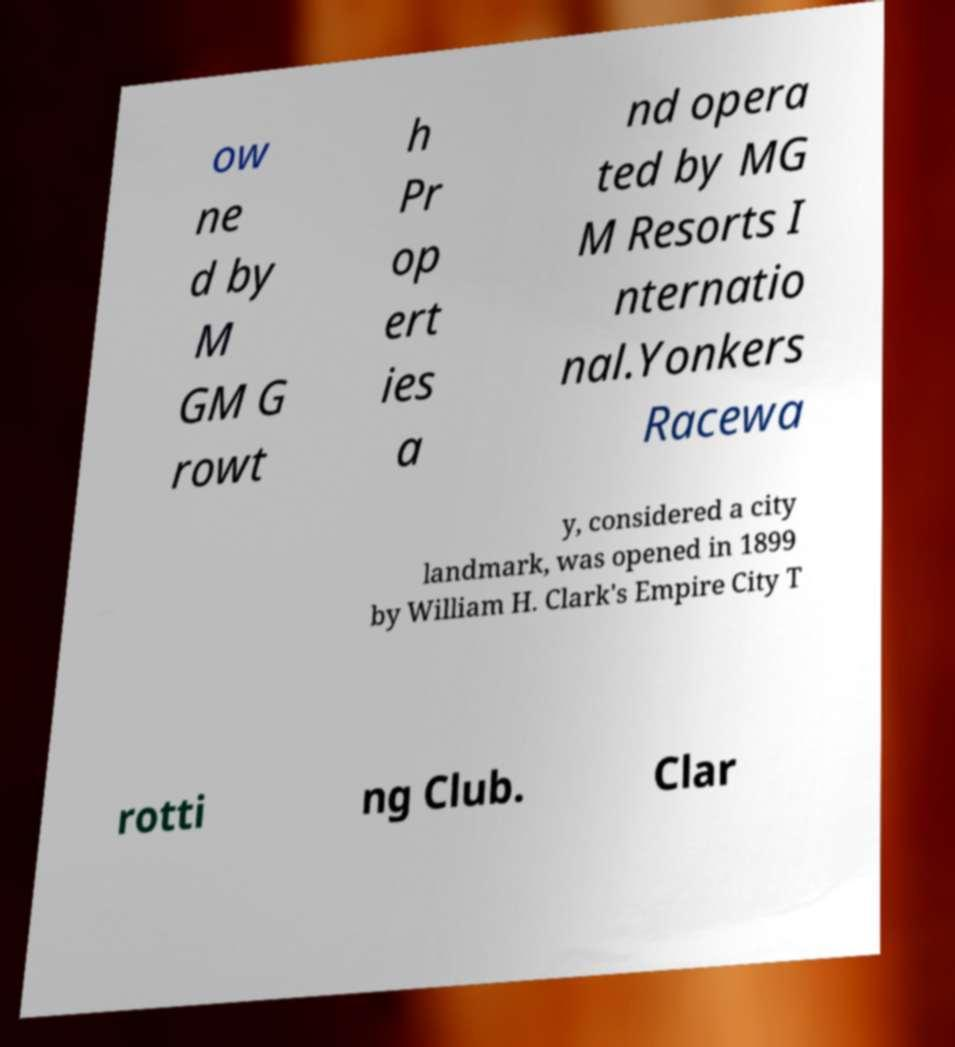Please identify and transcribe the text found in this image. ow ne d by M GM G rowt h Pr op ert ies a nd opera ted by MG M Resorts I nternatio nal.Yonkers Racewa y, considered a city landmark, was opened in 1899 by William H. Clark's Empire City T rotti ng Club. Clar 